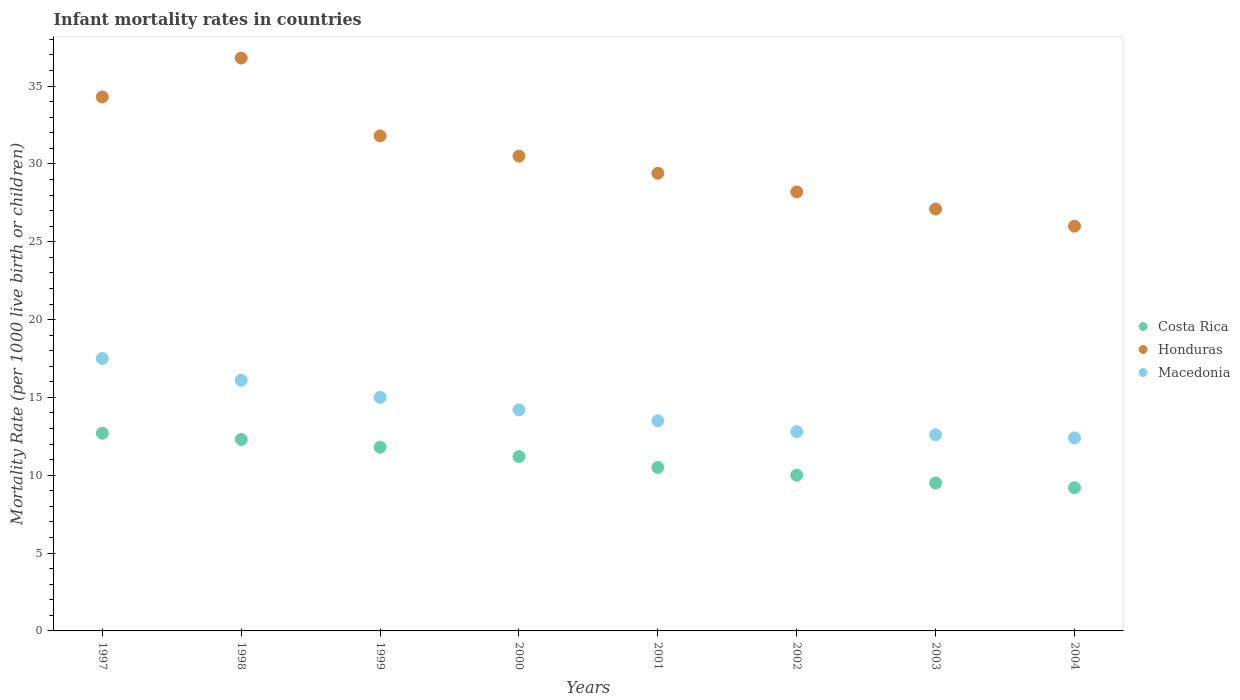How many different coloured dotlines are there?
Offer a very short reply. 3. Is the number of dotlines equal to the number of legend labels?
Your answer should be very brief. Yes. What is the infant mortality rate in Honduras in 2004?
Keep it short and to the point. 26. Across all years, what is the maximum infant mortality rate in Macedonia?
Provide a short and direct response. 17.5. In which year was the infant mortality rate in Honduras maximum?
Offer a terse response. 1998. In which year was the infant mortality rate in Macedonia minimum?
Ensure brevity in your answer.  2004. What is the total infant mortality rate in Macedonia in the graph?
Your answer should be compact. 114.1. What is the difference between the infant mortality rate in Macedonia in 2001 and that in 2003?
Your answer should be compact. 0.9. What is the difference between the infant mortality rate in Honduras in 1997 and the infant mortality rate in Macedonia in 2001?
Offer a terse response. 20.8. What is the average infant mortality rate in Honduras per year?
Give a very brief answer. 30.51. In the year 2004, what is the difference between the infant mortality rate in Honduras and infant mortality rate in Macedonia?
Ensure brevity in your answer.  13.6. In how many years, is the infant mortality rate in Honduras greater than 4?
Offer a very short reply. 8. What is the ratio of the infant mortality rate in Costa Rica in 2000 to that in 2002?
Provide a short and direct response. 1.12. Is the infant mortality rate in Costa Rica in 1997 less than that in 1998?
Provide a succinct answer. No. Is the difference between the infant mortality rate in Honduras in 1998 and 2004 greater than the difference between the infant mortality rate in Macedonia in 1998 and 2004?
Offer a very short reply. Yes. What is the difference between the highest and the second highest infant mortality rate in Honduras?
Offer a very short reply. 2.5. In how many years, is the infant mortality rate in Macedonia greater than the average infant mortality rate in Macedonia taken over all years?
Offer a terse response. 3. Is it the case that in every year, the sum of the infant mortality rate in Macedonia and infant mortality rate in Honduras  is greater than the infant mortality rate in Costa Rica?
Give a very brief answer. Yes. Does the infant mortality rate in Honduras monotonically increase over the years?
Make the answer very short. No. Does the graph contain any zero values?
Make the answer very short. No. Does the graph contain grids?
Keep it short and to the point. No. Where does the legend appear in the graph?
Keep it short and to the point. Center right. How many legend labels are there?
Provide a short and direct response. 3. What is the title of the graph?
Provide a succinct answer. Infant mortality rates in countries. Does "Small states" appear as one of the legend labels in the graph?
Provide a succinct answer. No. What is the label or title of the Y-axis?
Ensure brevity in your answer.  Mortality Rate (per 1000 live birth or children). What is the Mortality Rate (per 1000 live birth or children) in Honduras in 1997?
Provide a succinct answer. 34.3. What is the Mortality Rate (per 1000 live birth or children) in Costa Rica in 1998?
Give a very brief answer. 12.3. What is the Mortality Rate (per 1000 live birth or children) in Honduras in 1998?
Provide a short and direct response. 36.8. What is the Mortality Rate (per 1000 live birth or children) in Honduras in 1999?
Make the answer very short. 31.8. What is the Mortality Rate (per 1000 live birth or children) of Costa Rica in 2000?
Keep it short and to the point. 11.2. What is the Mortality Rate (per 1000 live birth or children) of Honduras in 2000?
Make the answer very short. 30.5. What is the Mortality Rate (per 1000 live birth or children) of Costa Rica in 2001?
Keep it short and to the point. 10.5. What is the Mortality Rate (per 1000 live birth or children) in Honduras in 2001?
Provide a succinct answer. 29.4. What is the Mortality Rate (per 1000 live birth or children) of Honduras in 2002?
Offer a terse response. 28.2. What is the Mortality Rate (per 1000 live birth or children) in Honduras in 2003?
Provide a succinct answer. 27.1. What is the Mortality Rate (per 1000 live birth or children) of Macedonia in 2003?
Your response must be concise. 12.6. What is the Mortality Rate (per 1000 live birth or children) of Costa Rica in 2004?
Your answer should be very brief. 9.2. What is the Mortality Rate (per 1000 live birth or children) of Honduras in 2004?
Make the answer very short. 26. What is the Mortality Rate (per 1000 live birth or children) in Macedonia in 2004?
Your answer should be very brief. 12.4. Across all years, what is the maximum Mortality Rate (per 1000 live birth or children) in Costa Rica?
Provide a short and direct response. 12.7. Across all years, what is the maximum Mortality Rate (per 1000 live birth or children) of Honduras?
Provide a short and direct response. 36.8. Across all years, what is the minimum Mortality Rate (per 1000 live birth or children) in Honduras?
Keep it short and to the point. 26. What is the total Mortality Rate (per 1000 live birth or children) of Costa Rica in the graph?
Your answer should be compact. 87.2. What is the total Mortality Rate (per 1000 live birth or children) of Honduras in the graph?
Provide a short and direct response. 244.1. What is the total Mortality Rate (per 1000 live birth or children) of Macedonia in the graph?
Your answer should be compact. 114.1. What is the difference between the Mortality Rate (per 1000 live birth or children) in Honduras in 1997 and that in 1999?
Give a very brief answer. 2.5. What is the difference between the Mortality Rate (per 1000 live birth or children) in Costa Rica in 1997 and that in 2000?
Give a very brief answer. 1.5. What is the difference between the Mortality Rate (per 1000 live birth or children) of Macedonia in 1997 and that in 2000?
Ensure brevity in your answer.  3.3. What is the difference between the Mortality Rate (per 1000 live birth or children) in Macedonia in 1997 and that in 2001?
Provide a succinct answer. 4. What is the difference between the Mortality Rate (per 1000 live birth or children) in Honduras in 1997 and that in 2002?
Your answer should be very brief. 6.1. What is the difference between the Mortality Rate (per 1000 live birth or children) of Costa Rica in 1997 and that in 2003?
Provide a succinct answer. 3.2. What is the difference between the Mortality Rate (per 1000 live birth or children) of Honduras in 1997 and that in 2003?
Offer a terse response. 7.2. What is the difference between the Mortality Rate (per 1000 live birth or children) of Macedonia in 1997 and that in 2003?
Your answer should be very brief. 4.9. What is the difference between the Mortality Rate (per 1000 live birth or children) of Honduras in 1997 and that in 2004?
Your answer should be very brief. 8.3. What is the difference between the Mortality Rate (per 1000 live birth or children) in Macedonia in 1998 and that in 1999?
Ensure brevity in your answer.  1.1. What is the difference between the Mortality Rate (per 1000 live birth or children) of Honduras in 1998 and that in 2000?
Offer a terse response. 6.3. What is the difference between the Mortality Rate (per 1000 live birth or children) in Macedonia in 1998 and that in 2000?
Ensure brevity in your answer.  1.9. What is the difference between the Mortality Rate (per 1000 live birth or children) in Costa Rica in 1998 and that in 2001?
Give a very brief answer. 1.8. What is the difference between the Mortality Rate (per 1000 live birth or children) in Macedonia in 1998 and that in 2001?
Offer a terse response. 2.6. What is the difference between the Mortality Rate (per 1000 live birth or children) of Costa Rica in 1998 and that in 2002?
Give a very brief answer. 2.3. What is the difference between the Mortality Rate (per 1000 live birth or children) of Honduras in 1998 and that in 2004?
Ensure brevity in your answer.  10.8. What is the difference between the Mortality Rate (per 1000 live birth or children) in Macedonia in 1998 and that in 2004?
Your response must be concise. 3.7. What is the difference between the Mortality Rate (per 1000 live birth or children) in Costa Rica in 1999 and that in 2000?
Ensure brevity in your answer.  0.6. What is the difference between the Mortality Rate (per 1000 live birth or children) of Macedonia in 1999 and that in 2000?
Provide a short and direct response. 0.8. What is the difference between the Mortality Rate (per 1000 live birth or children) of Honduras in 1999 and that in 2001?
Make the answer very short. 2.4. What is the difference between the Mortality Rate (per 1000 live birth or children) in Costa Rica in 1999 and that in 2002?
Ensure brevity in your answer.  1.8. What is the difference between the Mortality Rate (per 1000 live birth or children) in Macedonia in 1999 and that in 2002?
Provide a short and direct response. 2.2. What is the difference between the Mortality Rate (per 1000 live birth or children) of Costa Rica in 1999 and that in 2003?
Provide a short and direct response. 2.3. What is the difference between the Mortality Rate (per 1000 live birth or children) of Honduras in 1999 and that in 2003?
Ensure brevity in your answer.  4.7. What is the difference between the Mortality Rate (per 1000 live birth or children) in Honduras in 1999 and that in 2004?
Offer a very short reply. 5.8. What is the difference between the Mortality Rate (per 1000 live birth or children) of Costa Rica in 2000 and that in 2001?
Offer a very short reply. 0.7. What is the difference between the Mortality Rate (per 1000 live birth or children) in Honduras in 2000 and that in 2001?
Provide a short and direct response. 1.1. What is the difference between the Mortality Rate (per 1000 live birth or children) in Costa Rica in 2000 and that in 2002?
Your answer should be compact. 1.2. What is the difference between the Mortality Rate (per 1000 live birth or children) of Honduras in 2000 and that in 2002?
Your answer should be compact. 2.3. What is the difference between the Mortality Rate (per 1000 live birth or children) in Macedonia in 2000 and that in 2002?
Ensure brevity in your answer.  1.4. What is the difference between the Mortality Rate (per 1000 live birth or children) of Macedonia in 2000 and that in 2003?
Your response must be concise. 1.6. What is the difference between the Mortality Rate (per 1000 live birth or children) of Honduras in 2000 and that in 2004?
Your response must be concise. 4.5. What is the difference between the Mortality Rate (per 1000 live birth or children) of Honduras in 2001 and that in 2002?
Offer a terse response. 1.2. What is the difference between the Mortality Rate (per 1000 live birth or children) in Macedonia in 2001 and that in 2002?
Offer a very short reply. 0.7. What is the difference between the Mortality Rate (per 1000 live birth or children) of Macedonia in 2001 and that in 2003?
Offer a terse response. 0.9. What is the difference between the Mortality Rate (per 1000 live birth or children) in Costa Rica in 2002 and that in 2003?
Provide a short and direct response. 0.5. What is the difference between the Mortality Rate (per 1000 live birth or children) in Macedonia in 2002 and that in 2003?
Ensure brevity in your answer.  0.2. What is the difference between the Mortality Rate (per 1000 live birth or children) in Honduras in 2002 and that in 2004?
Offer a terse response. 2.2. What is the difference between the Mortality Rate (per 1000 live birth or children) of Costa Rica in 1997 and the Mortality Rate (per 1000 live birth or children) of Honduras in 1998?
Ensure brevity in your answer.  -24.1. What is the difference between the Mortality Rate (per 1000 live birth or children) of Costa Rica in 1997 and the Mortality Rate (per 1000 live birth or children) of Macedonia in 1998?
Ensure brevity in your answer.  -3.4. What is the difference between the Mortality Rate (per 1000 live birth or children) in Honduras in 1997 and the Mortality Rate (per 1000 live birth or children) in Macedonia in 1998?
Provide a succinct answer. 18.2. What is the difference between the Mortality Rate (per 1000 live birth or children) of Costa Rica in 1997 and the Mortality Rate (per 1000 live birth or children) of Honduras in 1999?
Offer a very short reply. -19.1. What is the difference between the Mortality Rate (per 1000 live birth or children) in Honduras in 1997 and the Mortality Rate (per 1000 live birth or children) in Macedonia in 1999?
Ensure brevity in your answer.  19.3. What is the difference between the Mortality Rate (per 1000 live birth or children) in Costa Rica in 1997 and the Mortality Rate (per 1000 live birth or children) in Honduras in 2000?
Your response must be concise. -17.8. What is the difference between the Mortality Rate (per 1000 live birth or children) in Honduras in 1997 and the Mortality Rate (per 1000 live birth or children) in Macedonia in 2000?
Ensure brevity in your answer.  20.1. What is the difference between the Mortality Rate (per 1000 live birth or children) in Costa Rica in 1997 and the Mortality Rate (per 1000 live birth or children) in Honduras in 2001?
Provide a short and direct response. -16.7. What is the difference between the Mortality Rate (per 1000 live birth or children) in Honduras in 1997 and the Mortality Rate (per 1000 live birth or children) in Macedonia in 2001?
Your response must be concise. 20.8. What is the difference between the Mortality Rate (per 1000 live birth or children) of Costa Rica in 1997 and the Mortality Rate (per 1000 live birth or children) of Honduras in 2002?
Give a very brief answer. -15.5. What is the difference between the Mortality Rate (per 1000 live birth or children) of Costa Rica in 1997 and the Mortality Rate (per 1000 live birth or children) of Macedonia in 2002?
Your answer should be compact. -0.1. What is the difference between the Mortality Rate (per 1000 live birth or children) in Costa Rica in 1997 and the Mortality Rate (per 1000 live birth or children) in Honduras in 2003?
Make the answer very short. -14.4. What is the difference between the Mortality Rate (per 1000 live birth or children) in Honduras in 1997 and the Mortality Rate (per 1000 live birth or children) in Macedonia in 2003?
Provide a short and direct response. 21.7. What is the difference between the Mortality Rate (per 1000 live birth or children) of Costa Rica in 1997 and the Mortality Rate (per 1000 live birth or children) of Honduras in 2004?
Your answer should be very brief. -13.3. What is the difference between the Mortality Rate (per 1000 live birth or children) of Costa Rica in 1997 and the Mortality Rate (per 1000 live birth or children) of Macedonia in 2004?
Your answer should be very brief. 0.3. What is the difference between the Mortality Rate (per 1000 live birth or children) of Honduras in 1997 and the Mortality Rate (per 1000 live birth or children) of Macedonia in 2004?
Your response must be concise. 21.9. What is the difference between the Mortality Rate (per 1000 live birth or children) in Costa Rica in 1998 and the Mortality Rate (per 1000 live birth or children) in Honduras in 1999?
Provide a succinct answer. -19.5. What is the difference between the Mortality Rate (per 1000 live birth or children) of Costa Rica in 1998 and the Mortality Rate (per 1000 live birth or children) of Macedonia in 1999?
Your response must be concise. -2.7. What is the difference between the Mortality Rate (per 1000 live birth or children) of Honduras in 1998 and the Mortality Rate (per 1000 live birth or children) of Macedonia in 1999?
Give a very brief answer. 21.8. What is the difference between the Mortality Rate (per 1000 live birth or children) in Costa Rica in 1998 and the Mortality Rate (per 1000 live birth or children) in Honduras in 2000?
Provide a succinct answer. -18.2. What is the difference between the Mortality Rate (per 1000 live birth or children) of Honduras in 1998 and the Mortality Rate (per 1000 live birth or children) of Macedonia in 2000?
Keep it short and to the point. 22.6. What is the difference between the Mortality Rate (per 1000 live birth or children) of Costa Rica in 1998 and the Mortality Rate (per 1000 live birth or children) of Honduras in 2001?
Offer a very short reply. -17.1. What is the difference between the Mortality Rate (per 1000 live birth or children) of Costa Rica in 1998 and the Mortality Rate (per 1000 live birth or children) of Macedonia in 2001?
Provide a short and direct response. -1.2. What is the difference between the Mortality Rate (per 1000 live birth or children) of Honduras in 1998 and the Mortality Rate (per 1000 live birth or children) of Macedonia in 2001?
Your answer should be compact. 23.3. What is the difference between the Mortality Rate (per 1000 live birth or children) in Costa Rica in 1998 and the Mortality Rate (per 1000 live birth or children) in Honduras in 2002?
Provide a short and direct response. -15.9. What is the difference between the Mortality Rate (per 1000 live birth or children) of Honduras in 1998 and the Mortality Rate (per 1000 live birth or children) of Macedonia in 2002?
Your answer should be very brief. 24. What is the difference between the Mortality Rate (per 1000 live birth or children) in Costa Rica in 1998 and the Mortality Rate (per 1000 live birth or children) in Honduras in 2003?
Offer a terse response. -14.8. What is the difference between the Mortality Rate (per 1000 live birth or children) of Costa Rica in 1998 and the Mortality Rate (per 1000 live birth or children) of Macedonia in 2003?
Your response must be concise. -0.3. What is the difference between the Mortality Rate (per 1000 live birth or children) in Honduras in 1998 and the Mortality Rate (per 1000 live birth or children) in Macedonia in 2003?
Your answer should be very brief. 24.2. What is the difference between the Mortality Rate (per 1000 live birth or children) in Costa Rica in 1998 and the Mortality Rate (per 1000 live birth or children) in Honduras in 2004?
Your response must be concise. -13.7. What is the difference between the Mortality Rate (per 1000 live birth or children) of Honduras in 1998 and the Mortality Rate (per 1000 live birth or children) of Macedonia in 2004?
Provide a short and direct response. 24.4. What is the difference between the Mortality Rate (per 1000 live birth or children) in Costa Rica in 1999 and the Mortality Rate (per 1000 live birth or children) in Honduras in 2000?
Your answer should be very brief. -18.7. What is the difference between the Mortality Rate (per 1000 live birth or children) in Costa Rica in 1999 and the Mortality Rate (per 1000 live birth or children) in Macedonia in 2000?
Your answer should be very brief. -2.4. What is the difference between the Mortality Rate (per 1000 live birth or children) of Costa Rica in 1999 and the Mortality Rate (per 1000 live birth or children) of Honduras in 2001?
Your answer should be compact. -17.6. What is the difference between the Mortality Rate (per 1000 live birth or children) of Costa Rica in 1999 and the Mortality Rate (per 1000 live birth or children) of Macedonia in 2001?
Offer a terse response. -1.7. What is the difference between the Mortality Rate (per 1000 live birth or children) of Costa Rica in 1999 and the Mortality Rate (per 1000 live birth or children) of Honduras in 2002?
Offer a terse response. -16.4. What is the difference between the Mortality Rate (per 1000 live birth or children) of Costa Rica in 1999 and the Mortality Rate (per 1000 live birth or children) of Honduras in 2003?
Offer a terse response. -15.3. What is the difference between the Mortality Rate (per 1000 live birth or children) in Honduras in 1999 and the Mortality Rate (per 1000 live birth or children) in Macedonia in 2004?
Offer a very short reply. 19.4. What is the difference between the Mortality Rate (per 1000 live birth or children) in Costa Rica in 2000 and the Mortality Rate (per 1000 live birth or children) in Honduras in 2001?
Provide a short and direct response. -18.2. What is the difference between the Mortality Rate (per 1000 live birth or children) of Costa Rica in 2000 and the Mortality Rate (per 1000 live birth or children) of Honduras in 2002?
Your answer should be compact. -17. What is the difference between the Mortality Rate (per 1000 live birth or children) in Costa Rica in 2000 and the Mortality Rate (per 1000 live birth or children) in Macedonia in 2002?
Your answer should be compact. -1.6. What is the difference between the Mortality Rate (per 1000 live birth or children) of Honduras in 2000 and the Mortality Rate (per 1000 live birth or children) of Macedonia in 2002?
Your answer should be very brief. 17.7. What is the difference between the Mortality Rate (per 1000 live birth or children) in Costa Rica in 2000 and the Mortality Rate (per 1000 live birth or children) in Honduras in 2003?
Your answer should be compact. -15.9. What is the difference between the Mortality Rate (per 1000 live birth or children) in Costa Rica in 2000 and the Mortality Rate (per 1000 live birth or children) in Macedonia in 2003?
Offer a terse response. -1.4. What is the difference between the Mortality Rate (per 1000 live birth or children) of Honduras in 2000 and the Mortality Rate (per 1000 live birth or children) of Macedonia in 2003?
Your answer should be very brief. 17.9. What is the difference between the Mortality Rate (per 1000 live birth or children) in Costa Rica in 2000 and the Mortality Rate (per 1000 live birth or children) in Honduras in 2004?
Keep it short and to the point. -14.8. What is the difference between the Mortality Rate (per 1000 live birth or children) in Costa Rica in 2001 and the Mortality Rate (per 1000 live birth or children) in Honduras in 2002?
Your response must be concise. -17.7. What is the difference between the Mortality Rate (per 1000 live birth or children) in Costa Rica in 2001 and the Mortality Rate (per 1000 live birth or children) in Macedonia in 2002?
Provide a succinct answer. -2.3. What is the difference between the Mortality Rate (per 1000 live birth or children) in Costa Rica in 2001 and the Mortality Rate (per 1000 live birth or children) in Honduras in 2003?
Offer a terse response. -16.6. What is the difference between the Mortality Rate (per 1000 live birth or children) of Costa Rica in 2001 and the Mortality Rate (per 1000 live birth or children) of Macedonia in 2003?
Your answer should be compact. -2.1. What is the difference between the Mortality Rate (per 1000 live birth or children) of Costa Rica in 2001 and the Mortality Rate (per 1000 live birth or children) of Honduras in 2004?
Your answer should be compact. -15.5. What is the difference between the Mortality Rate (per 1000 live birth or children) in Costa Rica in 2001 and the Mortality Rate (per 1000 live birth or children) in Macedonia in 2004?
Make the answer very short. -1.9. What is the difference between the Mortality Rate (per 1000 live birth or children) in Honduras in 2001 and the Mortality Rate (per 1000 live birth or children) in Macedonia in 2004?
Your answer should be compact. 17. What is the difference between the Mortality Rate (per 1000 live birth or children) in Costa Rica in 2002 and the Mortality Rate (per 1000 live birth or children) in Honduras in 2003?
Provide a succinct answer. -17.1. What is the difference between the Mortality Rate (per 1000 live birth or children) in Costa Rica in 2002 and the Mortality Rate (per 1000 live birth or children) in Macedonia in 2003?
Your answer should be compact. -2.6. What is the difference between the Mortality Rate (per 1000 live birth or children) in Honduras in 2002 and the Mortality Rate (per 1000 live birth or children) in Macedonia in 2003?
Offer a very short reply. 15.6. What is the difference between the Mortality Rate (per 1000 live birth or children) of Costa Rica in 2002 and the Mortality Rate (per 1000 live birth or children) of Macedonia in 2004?
Provide a short and direct response. -2.4. What is the difference between the Mortality Rate (per 1000 live birth or children) of Honduras in 2002 and the Mortality Rate (per 1000 live birth or children) of Macedonia in 2004?
Keep it short and to the point. 15.8. What is the difference between the Mortality Rate (per 1000 live birth or children) in Costa Rica in 2003 and the Mortality Rate (per 1000 live birth or children) in Honduras in 2004?
Make the answer very short. -16.5. What is the difference between the Mortality Rate (per 1000 live birth or children) in Costa Rica in 2003 and the Mortality Rate (per 1000 live birth or children) in Macedonia in 2004?
Offer a terse response. -2.9. What is the average Mortality Rate (per 1000 live birth or children) of Honduras per year?
Your answer should be very brief. 30.51. What is the average Mortality Rate (per 1000 live birth or children) in Macedonia per year?
Provide a short and direct response. 14.26. In the year 1997, what is the difference between the Mortality Rate (per 1000 live birth or children) of Costa Rica and Mortality Rate (per 1000 live birth or children) of Honduras?
Provide a succinct answer. -21.6. In the year 1998, what is the difference between the Mortality Rate (per 1000 live birth or children) in Costa Rica and Mortality Rate (per 1000 live birth or children) in Honduras?
Offer a terse response. -24.5. In the year 1998, what is the difference between the Mortality Rate (per 1000 live birth or children) of Costa Rica and Mortality Rate (per 1000 live birth or children) of Macedonia?
Your answer should be very brief. -3.8. In the year 1998, what is the difference between the Mortality Rate (per 1000 live birth or children) in Honduras and Mortality Rate (per 1000 live birth or children) in Macedonia?
Give a very brief answer. 20.7. In the year 1999, what is the difference between the Mortality Rate (per 1000 live birth or children) of Honduras and Mortality Rate (per 1000 live birth or children) of Macedonia?
Give a very brief answer. 16.8. In the year 2000, what is the difference between the Mortality Rate (per 1000 live birth or children) of Costa Rica and Mortality Rate (per 1000 live birth or children) of Honduras?
Your answer should be compact. -19.3. In the year 2000, what is the difference between the Mortality Rate (per 1000 live birth or children) in Honduras and Mortality Rate (per 1000 live birth or children) in Macedonia?
Provide a short and direct response. 16.3. In the year 2001, what is the difference between the Mortality Rate (per 1000 live birth or children) of Costa Rica and Mortality Rate (per 1000 live birth or children) of Honduras?
Ensure brevity in your answer.  -18.9. In the year 2001, what is the difference between the Mortality Rate (per 1000 live birth or children) in Costa Rica and Mortality Rate (per 1000 live birth or children) in Macedonia?
Provide a succinct answer. -3. In the year 2001, what is the difference between the Mortality Rate (per 1000 live birth or children) of Honduras and Mortality Rate (per 1000 live birth or children) of Macedonia?
Your response must be concise. 15.9. In the year 2002, what is the difference between the Mortality Rate (per 1000 live birth or children) in Costa Rica and Mortality Rate (per 1000 live birth or children) in Honduras?
Offer a terse response. -18.2. In the year 2003, what is the difference between the Mortality Rate (per 1000 live birth or children) in Costa Rica and Mortality Rate (per 1000 live birth or children) in Honduras?
Your response must be concise. -17.6. In the year 2003, what is the difference between the Mortality Rate (per 1000 live birth or children) of Costa Rica and Mortality Rate (per 1000 live birth or children) of Macedonia?
Make the answer very short. -3.1. In the year 2004, what is the difference between the Mortality Rate (per 1000 live birth or children) in Costa Rica and Mortality Rate (per 1000 live birth or children) in Honduras?
Provide a short and direct response. -16.8. In the year 2004, what is the difference between the Mortality Rate (per 1000 live birth or children) of Costa Rica and Mortality Rate (per 1000 live birth or children) of Macedonia?
Ensure brevity in your answer.  -3.2. What is the ratio of the Mortality Rate (per 1000 live birth or children) in Costa Rica in 1997 to that in 1998?
Provide a succinct answer. 1.03. What is the ratio of the Mortality Rate (per 1000 live birth or children) of Honduras in 1997 to that in 1998?
Keep it short and to the point. 0.93. What is the ratio of the Mortality Rate (per 1000 live birth or children) in Macedonia in 1997 to that in 1998?
Give a very brief answer. 1.09. What is the ratio of the Mortality Rate (per 1000 live birth or children) in Costa Rica in 1997 to that in 1999?
Provide a succinct answer. 1.08. What is the ratio of the Mortality Rate (per 1000 live birth or children) in Honduras in 1997 to that in 1999?
Keep it short and to the point. 1.08. What is the ratio of the Mortality Rate (per 1000 live birth or children) in Costa Rica in 1997 to that in 2000?
Ensure brevity in your answer.  1.13. What is the ratio of the Mortality Rate (per 1000 live birth or children) of Honduras in 1997 to that in 2000?
Keep it short and to the point. 1.12. What is the ratio of the Mortality Rate (per 1000 live birth or children) in Macedonia in 1997 to that in 2000?
Your answer should be very brief. 1.23. What is the ratio of the Mortality Rate (per 1000 live birth or children) in Costa Rica in 1997 to that in 2001?
Your answer should be compact. 1.21. What is the ratio of the Mortality Rate (per 1000 live birth or children) in Macedonia in 1997 to that in 2001?
Provide a succinct answer. 1.3. What is the ratio of the Mortality Rate (per 1000 live birth or children) in Costa Rica in 1997 to that in 2002?
Make the answer very short. 1.27. What is the ratio of the Mortality Rate (per 1000 live birth or children) of Honduras in 1997 to that in 2002?
Your answer should be very brief. 1.22. What is the ratio of the Mortality Rate (per 1000 live birth or children) in Macedonia in 1997 to that in 2002?
Make the answer very short. 1.37. What is the ratio of the Mortality Rate (per 1000 live birth or children) in Costa Rica in 1997 to that in 2003?
Your answer should be very brief. 1.34. What is the ratio of the Mortality Rate (per 1000 live birth or children) of Honduras in 1997 to that in 2003?
Make the answer very short. 1.27. What is the ratio of the Mortality Rate (per 1000 live birth or children) in Macedonia in 1997 to that in 2003?
Make the answer very short. 1.39. What is the ratio of the Mortality Rate (per 1000 live birth or children) of Costa Rica in 1997 to that in 2004?
Make the answer very short. 1.38. What is the ratio of the Mortality Rate (per 1000 live birth or children) in Honduras in 1997 to that in 2004?
Offer a terse response. 1.32. What is the ratio of the Mortality Rate (per 1000 live birth or children) of Macedonia in 1997 to that in 2004?
Your response must be concise. 1.41. What is the ratio of the Mortality Rate (per 1000 live birth or children) of Costa Rica in 1998 to that in 1999?
Your answer should be very brief. 1.04. What is the ratio of the Mortality Rate (per 1000 live birth or children) of Honduras in 1998 to that in 1999?
Ensure brevity in your answer.  1.16. What is the ratio of the Mortality Rate (per 1000 live birth or children) of Macedonia in 1998 to that in 1999?
Your answer should be very brief. 1.07. What is the ratio of the Mortality Rate (per 1000 live birth or children) of Costa Rica in 1998 to that in 2000?
Offer a very short reply. 1.1. What is the ratio of the Mortality Rate (per 1000 live birth or children) in Honduras in 1998 to that in 2000?
Provide a succinct answer. 1.21. What is the ratio of the Mortality Rate (per 1000 live birth or children) of Macedonia in 1998 to that in 2000?
Keep it short and to the point. 1.13. What is the ratio of the Mortality Rate (per 1000 live birth or children) of Costa Rica in 1998 to that in 2001?
Keep it short and to the point. 1.17. What is the ratio of the Mortality Rate (per 1000 live birth or children) in Honduras in 1998 to that in 2001?
Provide a short and direct response. 1.25. What is the ratio of the Mortality Rate (per 1000 live birth or children) in Macedonia in 1998 to that in 2001?
Ensure brevity in your answer.  1.19. What is the ratio of the Mortality Rate (per 1000 live birth or children) of Costa Rica in 1998 to that in 2002?
Offer a very short reply. 1.23. What is the ratio of the Mortality Rate (per 1000 live birth or children) in Honduras in 1998 to that in 2002?
Offer a very short reply. 1.3. What is the ratio of the Mortality Rate (per 1000 live birth or children) in Macedonia in 1998 to that in 2002?
Provide a short and direct response. 1.26. What is the ratio of the Mortality Rate (per 1000 live birth or children) of Costa Rica in 1998 to that in 2003?
Provide a short and direct response. 1.29. What is the ratio of the Mortality Rate (per 1000 live birth or children) of Honduras in 1998 to that in 2003?
Make the answer very short. 1.36. What is the ratio of the Mortality Rate (per 1000 live birth or children) of Macedonia in 1998 to that in 2003?
Offer a very short reply. 1.28. What is the ratio of the Mortality Rate (per 1000 live birth or children) of Costa Rica in 1998 to that in 2004?
Your answer should be very brief. 1.34. What is the ratio of the Mortality Rate (per 1000 live birth or children) of Honduras in 1998 to that in 2004?
Your answer should be very brief. 1.42. What is the ratio of the Mortality Rate (per 1000 live birth or children) in Macedonia in 1998 to that in 2004?
Provide a succinct answer. 1.3. What is the ratio of the Mortality Rate (per 1000 live birth or children) of Costa Rica in 1999 to that in 2000?
Provide a short and direct response. 1.05. What is the ratio of the Mortality Rate (per 1000 live birth or children) in Honduras in 1999 to that in 2000?
Your answer should be compact. 1.04. What is the ratio of the Mortality Rate (per 1000 live birth or children) in Macedonia in 1999 to that in 2000?
Offer a very short reply. 1.06. What is the ratio of the Mortality Rate (per 1000 live birth or children) in Costa Rica in 1999 to that in 2001?
Your answer should be compact. 1.12. What is the ratio of the Mortality Rate (per 1000 live birth or children) in Honduras in 1999 to that in 2001?
Provide a short and direct response. 1.08. What is the ratio of the Mortality Rate (per 1000 live birth or children) of Costa Rica in 1999 to that in 2002?
Your answer should be compact. 1.18. What is the ratio of the Mortality Rate (per 1000 live birth or children) in Honduras in 1999 to that in 2002?
Your answer should be compact. 1.13. What is the ratio of the Mortality Rate (per 1000 live birth or children) of Macedonia in 1999 to that in 2002?
Your answer should be very brief. 1.17. What is the ratio of the Mortality Rate (per 1000 live birth or children) in Costa Rica in 1999 to that in 2003?
Provide a short and direct response. 1.24. What is the ratio of the Mortality Rate (per 1000 live birth or children) of Honduras in 1999 to that in 2003?
Your answer should be very brief. 1.17. What is the ratio of the Mortality Rate (per 1000 live birth or children) of Macedonia in 1999 to that in 2003?
Provide a succinct answer. 1.19. What is the ratio of the Mortality Rate (per 1000 live birth or children) of Costa Rica in 1999 to that in 2004?
Make the answer very short. 1.28. What is the ratio of the Mortality Rate (per 1000 live birth or children) of Honduras in 1999 to that in 2004?
Keep it short and to the point. 1.22. What is the ratio of the Mortality Rate (per 1000 live birth or children) in Macedonia in 1999 to that in 2004?
Keep it short and to the point. 1.21. What is the ratio of the Mortality Rate (per 1000 live birth or children) of Costa Rica in 2000 to that in 2001?
Keep it short and to the point. 1.07. What is the ratio of the Mortality Rate (per 1000 live birth or children) of Honduras in 2000 to that in 2001?
Offer a very short reply. 1.04. What is the ratio of the Mortality Rate (per 1000 live birth or children) in Macedonia in 2000 to that in 2001?
Provide a succinct answer. 1.05. What is the ratio of the Mortality Rate (per 1000 live birth or children) in Costa Rica in 2000 to that in 2002?
Give a very brief answer. 1.12. What is the ratio of the Mortality Rate (per 1000 live birth or children) of Honduras in 2000 to that in 2002?
Provide a short and direct response. 1.08. What is the ratio of the Mortality Rate (per 1000 live birth or children) in Macedonia in 2000 to that in 2002?
Provide a short and direct response. 1.11. What is the ratio of the Mortality Rate (per 1000 live birth or children) of Costa Rica in 2000 to that in 2003?
Your answer should be very brief. 1.18. What is the ratio of the Mortality Rate (per 1000 live birth or children) in Honduras in 2000 to that in 2003?
Give a very brief answer. 1.13. What is the ratio of the Mortality Rate (per 1000 live birth or children) of Macedonia in 2000 to that in 2003?
Provide a short and direct response. 1.13. What is the ratio of the Mortality Rate (per 1000 live birth or children) in Costa Rica in 2000 to that in 2004?
Give a very brief answer. 1.22. What is the ratio of the Mortality Rate (per 1000 live birth or children) of Honduras in 2000 to that in 2004?
Keep it short and to the point. 1.17. What is the ratio of the Mortality Rate (per 1000 live birth or children) in Macedonia in 2000 to that in 2004?
Provide a succinct answer. 1.15. What is the ratio of the Mortality Rate (per 1000 live birth or children) in Honduras in 2001 to that in 2002?
Your answer should be very brief. 1.04. What is the ratio of the Mortality Rate (per 1000 live birth or children) in Macedonia in 2001 to that in 2002?
Your answer should be compact. 1.05. What is the ratio of the Mortality Rate (per 1000 live birth or children) of Costa Rica in 2001 to that in 2003?
Give a very brief answer. 1.11. What is the ratio of the Mortality Rate (per 1000 live birth or children) of Honduras in 2001 to that in 2003?
Make the answer very short. 1.08. What is the ratio of the Mortality Rate (per 1000 live birth or children) in Macedonia in 2001 to that in 2003?
Make the answer very short. 1.07. What is the ratio of the Mortality Rate (per 1000 live birth or children) of Costa Rica in 2001 to that in 2004?
Offer a very short reply. 1.14. What is the ratio of the Mortality Rate (per 1000 live birth or children) in Honduras in 2001 to that in 2004?
Your answer should be compact. 1.13. What is the ratio of the Mortality Rate (per 1000 live birth or children) of Macedonia in 2001 to that in 2004?
Give a very brief answer. 1.09. What is the ratio of the Mortality Rate (per 1000 live birth or children) in Costa Rica in 2002 to that in 2003?
Your answer should be compact. 1.05. What is the ratio of the Mortality Rate (per 1000 live birth or children) of Honduras in 2002 to that in 2003?
Keep it short and to the point. 1.04. What is the ratio of the Mortality Rate (per 1000 live birth or children) in Macedonia in 2002 to that in 2003?
Ensure brevity in your answer.  1.02. What is the ratio of the Mortality Rate (per 1000 live birth or children) in Costa Rica in 2002 to that in 2004?
Keep it short and to the point. 1.09. What is the ratio of the Mortality Rate (per 1000 live birth or children) of Honduras in 2002 to that in 2004?
Provide a succinct answer. 1.08. What is the ratio of the Mortality Rate (per 1000 live birth or children) of Macedonia in 2002 to that in 2004?
Your answer should be very brief. 1.03. What is the ratio of the Mortality Rate (per 1000 live birth or children) in Costa Rica in 2003 to that in 2004?
Provide a succinct answer. 1.03. What is the ratio of the Mortality Rate (per 1000 live birth or children) of Honduras in 2003 to that in 2004?
Your answer should be compact. 1.04. What is the ratio of the Mortality Rate (per 1000 live birth or children) of Macedonia in 2003 to that in 2004?
Provide a succinct answer. 1.02. What is the difference between the highest and the second highest Mortality Rate (per 1000 live birth or children) in Costa Rica?
Give a very brief answer. 0.4. What is the difference between the highest and the second highest Mortality Rate (per 1000 live birth or children) in Honduras?
Provide a succinct answer. 2.5. What is the difference between the highest and the lowest Mortality Rate (per 1000 live birth or children) in Honduras?
Keep it short and to the point. 10.8. 